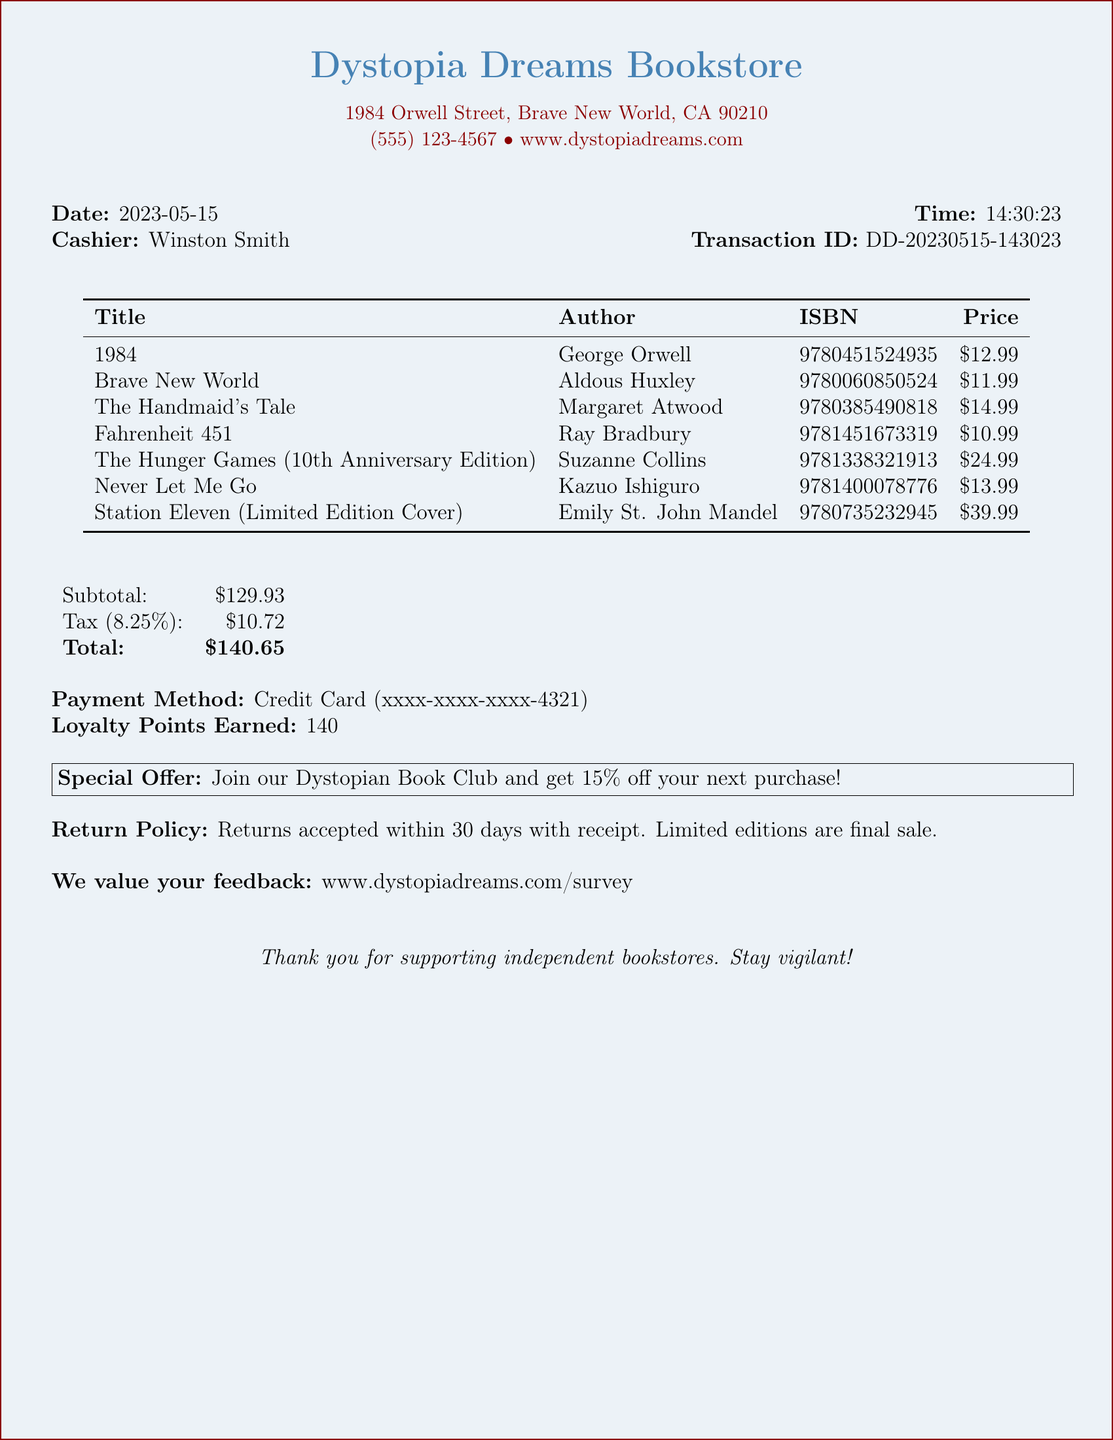What is the store name? The store name is clearly displayed at the top of the receipt.
Answer: Dystopia Dreams Bookstore What is the transaction date? The transaction date is mentioned in the document under the date section.
Answer: 2023-05-15 Who was the cashier? The cashier's name is provided in the cashier section of the receipt.
Answer: Winston Smith What is the subtotal of the purchase? The subtotal is specified clearly in the document.
Answer: $129.93 What is the price of "Station Eleven (Limited Edition Cover)"? The price for this specific item is listed in the items table.
Answer: $39.99 How many loyalty points were earned? The total loyalty points are mentioned towards the end of the receipt.
Answer: 140 What is the tax rate applied? The tax rate is indicated in the tax information of the document.
Answer: 8.25% What is the return policy duration? The return policy information outlines the time frame for returns.
Answer: 30 days What is the special offer? The special offer is highlighted in a separate box in the document.
Answer: Join our Dystopian Book Club and get 15% off your next purchase! 